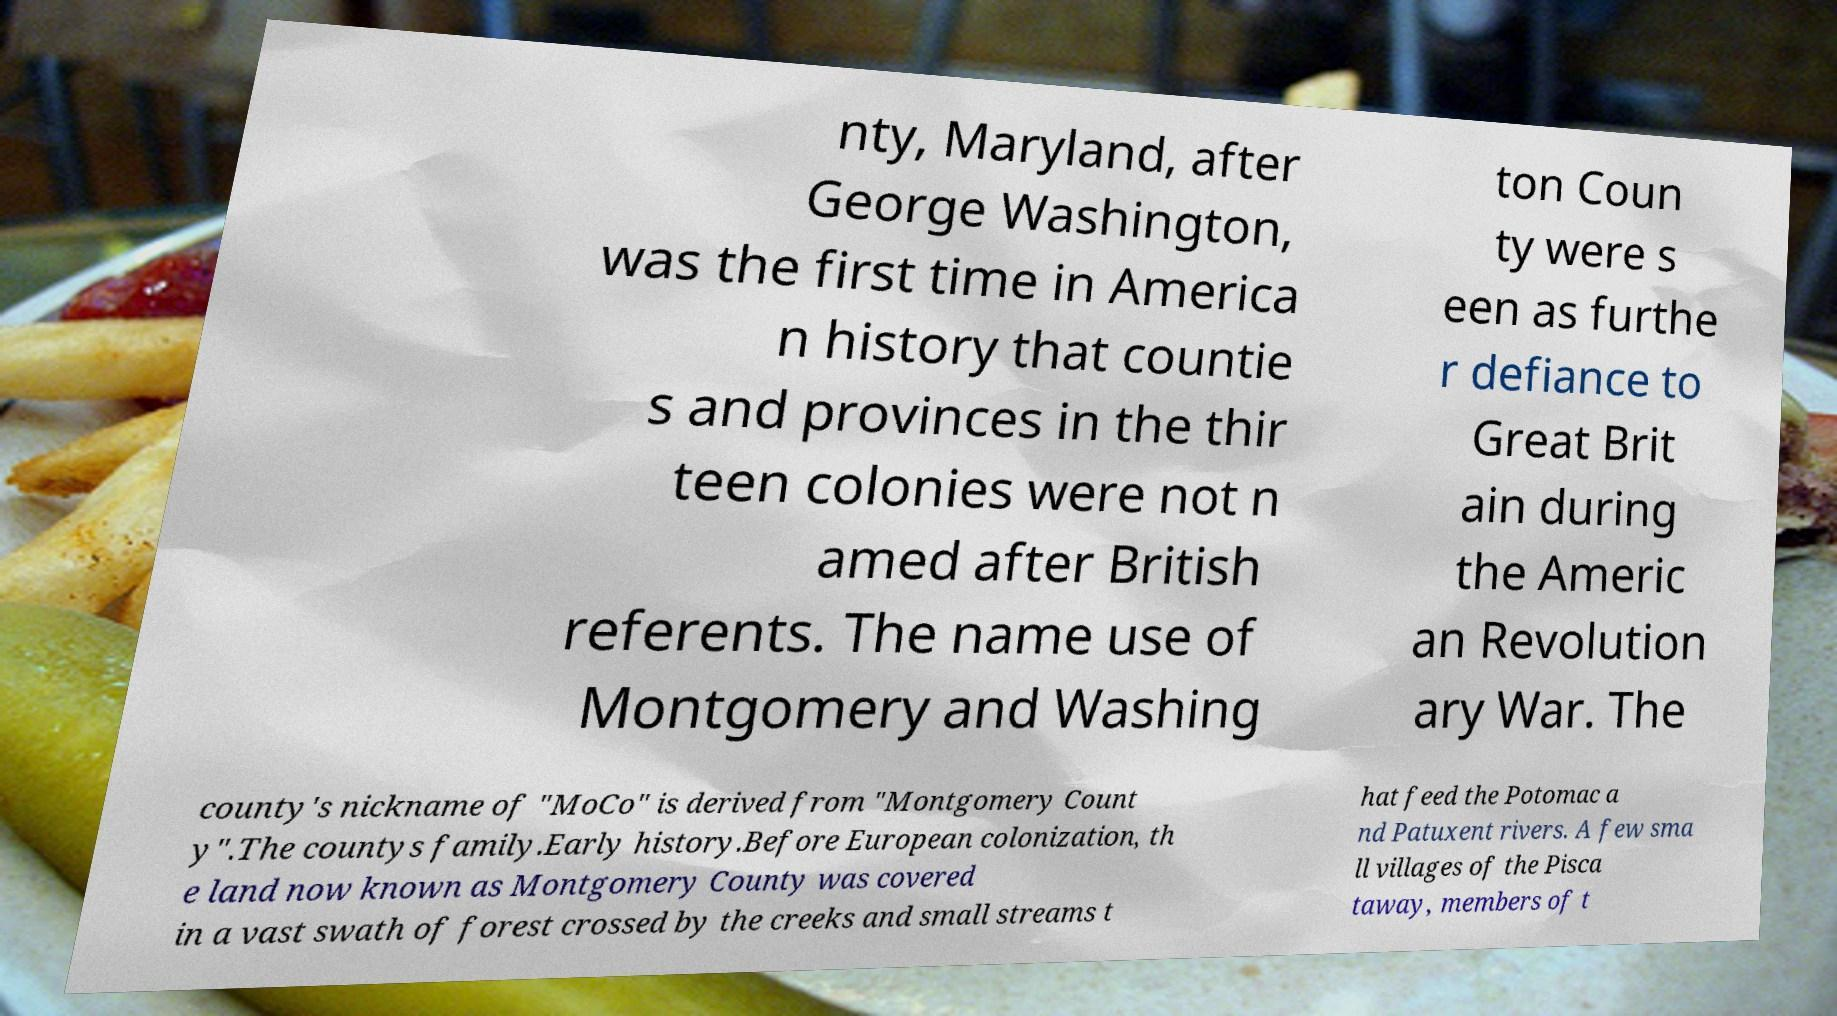Please identify and transcribe the text found in this image. nty, Maryland, after George Washington, was the first time in America n history that countie s and provinces in the thir teen colonies were not n amed after British referents. The name use of Montgomery and Washing ton Coun ty were s een as furthe r defiance to Great Brit ain during the Americ an Revolution ary War. The county's nickname of "MoCo" is derived from "Montgomery Count y".The countys family.Early history.Before European colonization, th e land now known as Montgomery County was covered in a vast swath of forest crossed by the creeks and small streams t hat feed the Potomac a nd Patuxent rivers. A few sma ll villages of the Pisca taway, members of t 